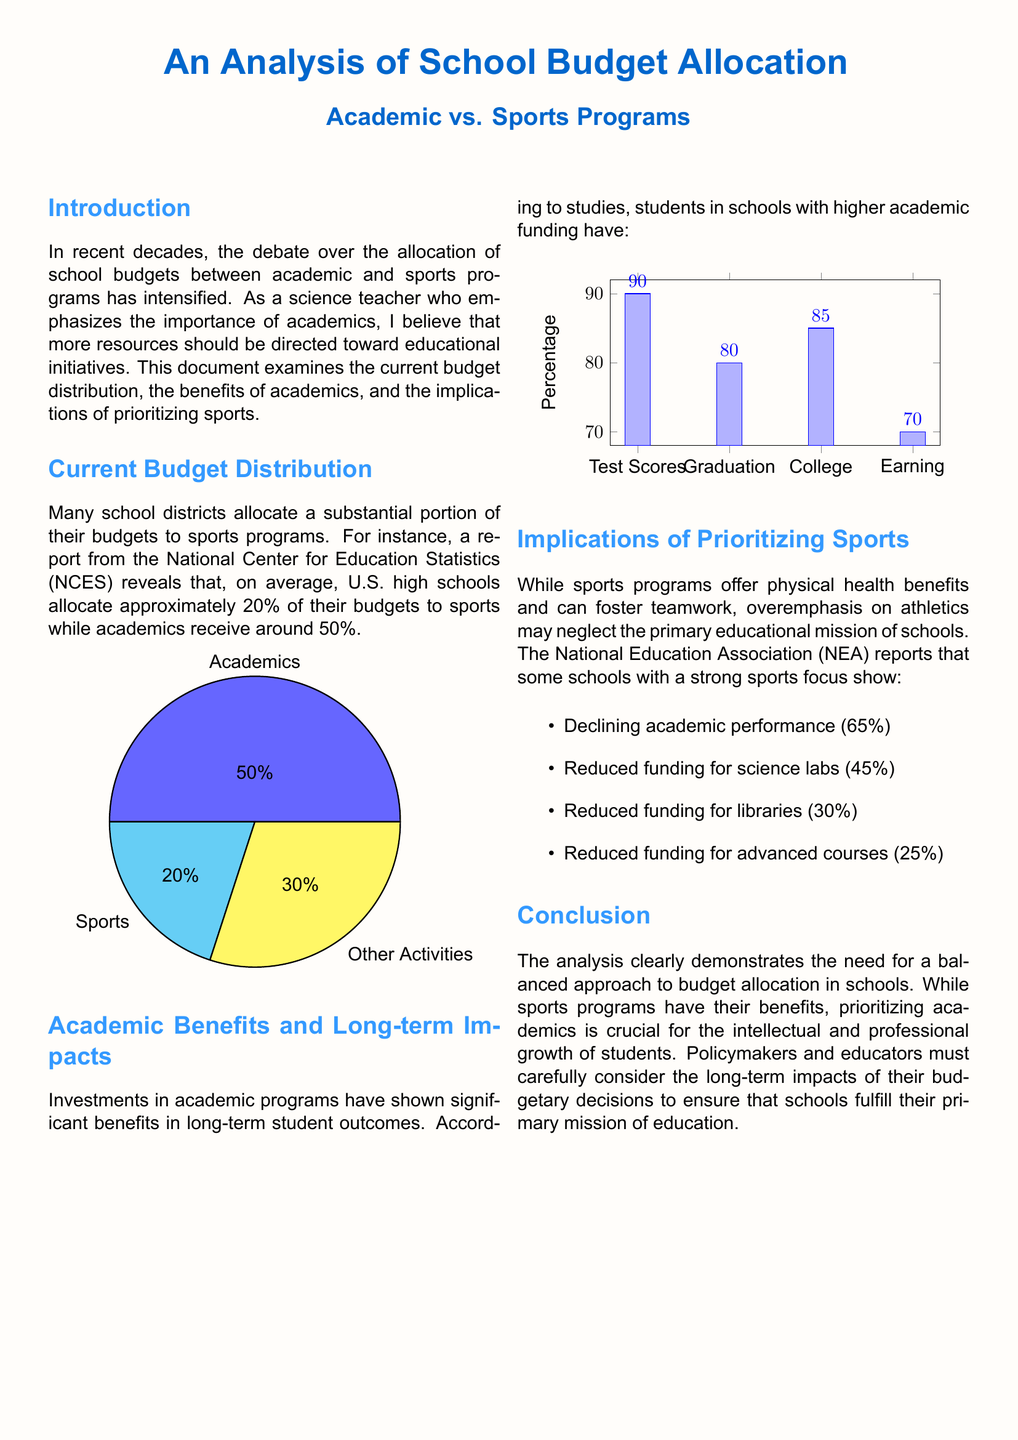What is the percentage of the budget allocated to academics? The document states that, on average, U.S. high schools allocate approximately 50% of their budgets to academics.
Answer: 50% What percentage of schools report declining academic performance due to sports focus? According to the NEA report in the document, 65% of schools with sports focus report declining academic performance.
Answer: 65% Which program receives the least funding according to the pie chart? The pie chart indicates that sports programs receive the least funding compared to academics and other activities.
Answer: Sports What percentage of funding is typically allocated to sports programs? The document mentions that, on average, U.S. high schools allocate approximately 20% of their budgets to sports.
Answer: 20% What is the percentage of students who graduate from schools with higher academic funding? The chart indicates that 80% of students graduate from schools with higher academic funding.
Answer: 80% What benefit is reported to result from increased academic funding? The document asserts that increased funding leads to higher test scores among students.
Answer: Test Scores What percentage of funding is reduced for advanced courses in schools with high sports focus? The document states that 25% of funding for advanced courses is reduced in schools with a strong sports focus.
Answer: 25% According to the document, what is the bar height for the percentage of college attendees from schools with higher academic investments? The bar graph shows that 85% of students attend college from schools with higher academic investments.
Answer: 85% 